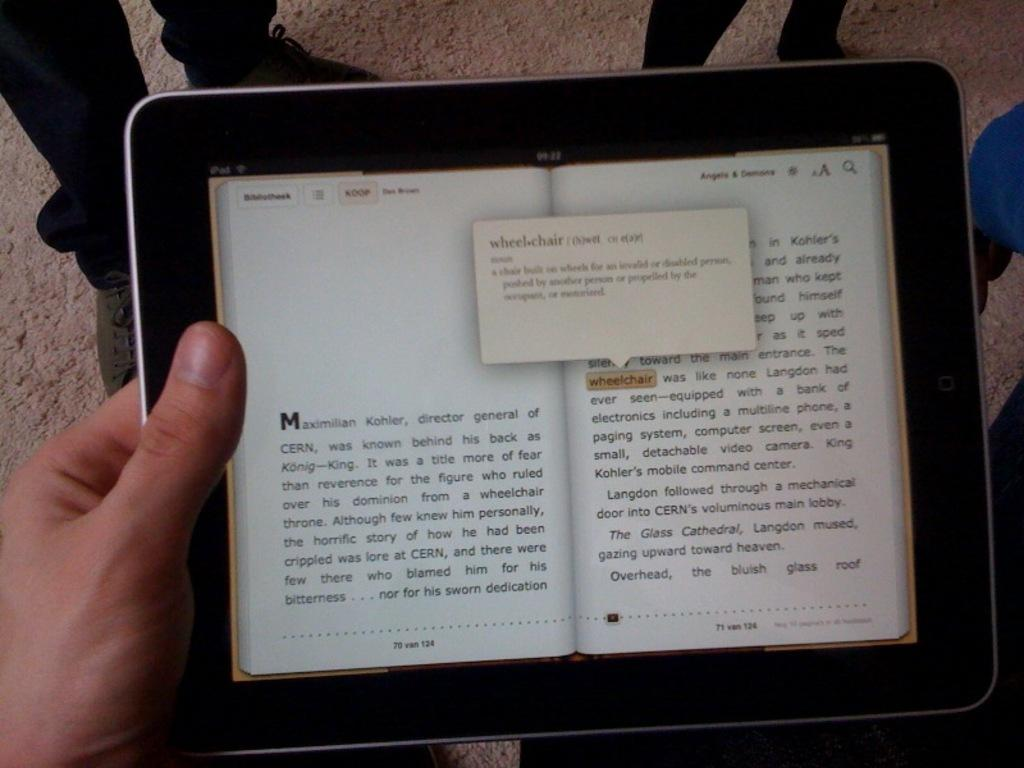What electronic device is visible in the image? There is a tablet in the image. What is displayed on the tablet's screen? The tablet's screen displays a book, and there is text visible on it. Can you describe the people in the background of the image? There are people standing in the background of the image. What type of instrument is being played by the person standing next to the hole in the image? There is no person playing an instrument or hole present in the image; it only features a tablet with a book displayed on its screen and people standing in the background. 